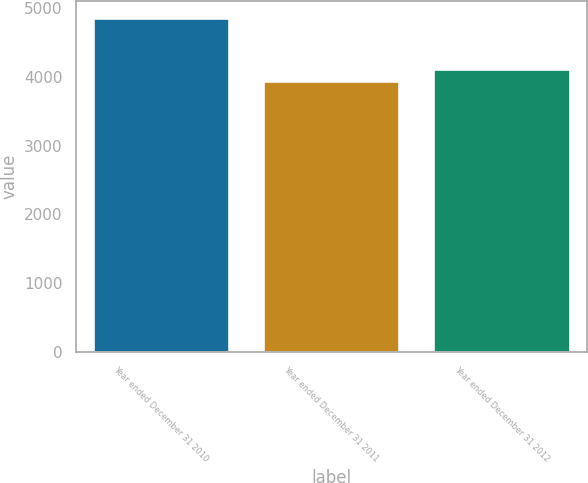Convert chart. <chart><loc_0><loc_0><loc_500><loc_500><bar_chart><fcel>Year ended December 31 2010<fcel>Year ended December 31 2011<fcel>Year ended December 31 2012<nl><fcel>4860<fcel>3939<fcel>4106<nl></chart> 